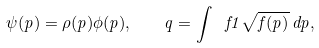<formula> <loc_0><loc_0><loc_500><loc_500>\psi ( p ) = \rho ( p ) \phi ( p ) , \quad q = \int \ f { 1 } { \sqrt { f ( p ) } } \, d p ,</formula> 